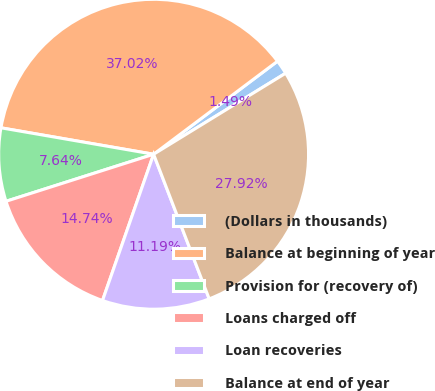Convert chart. <chart><loc_0><loc_0><loc_500><loc_500><pie_chart><fcel>(Dollars in thousands)<fcel>Balance at beginning of year<fcel>Provision for (recovery of)<fcel>Loans charged off<fcel>Loan recoveries<fcel>Balance at end of year<nl><fcel>1.49%<fcel>37.02%<fcel>7.64%<fcel>14.74%<fcel>11.19%<fcel>27.92%<nl></chart> 